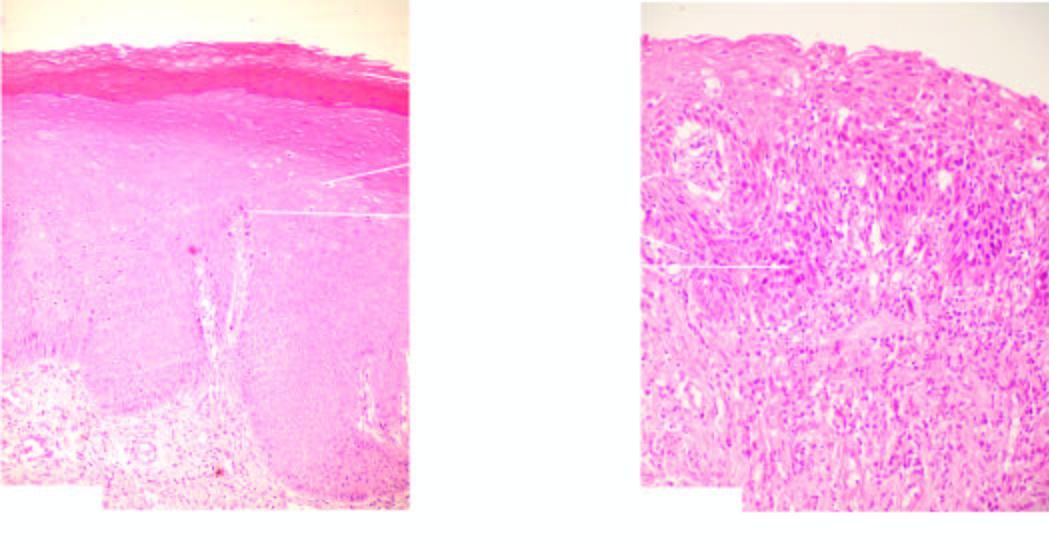do defects in any of the six show features of cytologic atypia and mitosis?
Answer the question using a single word or phrase. No 